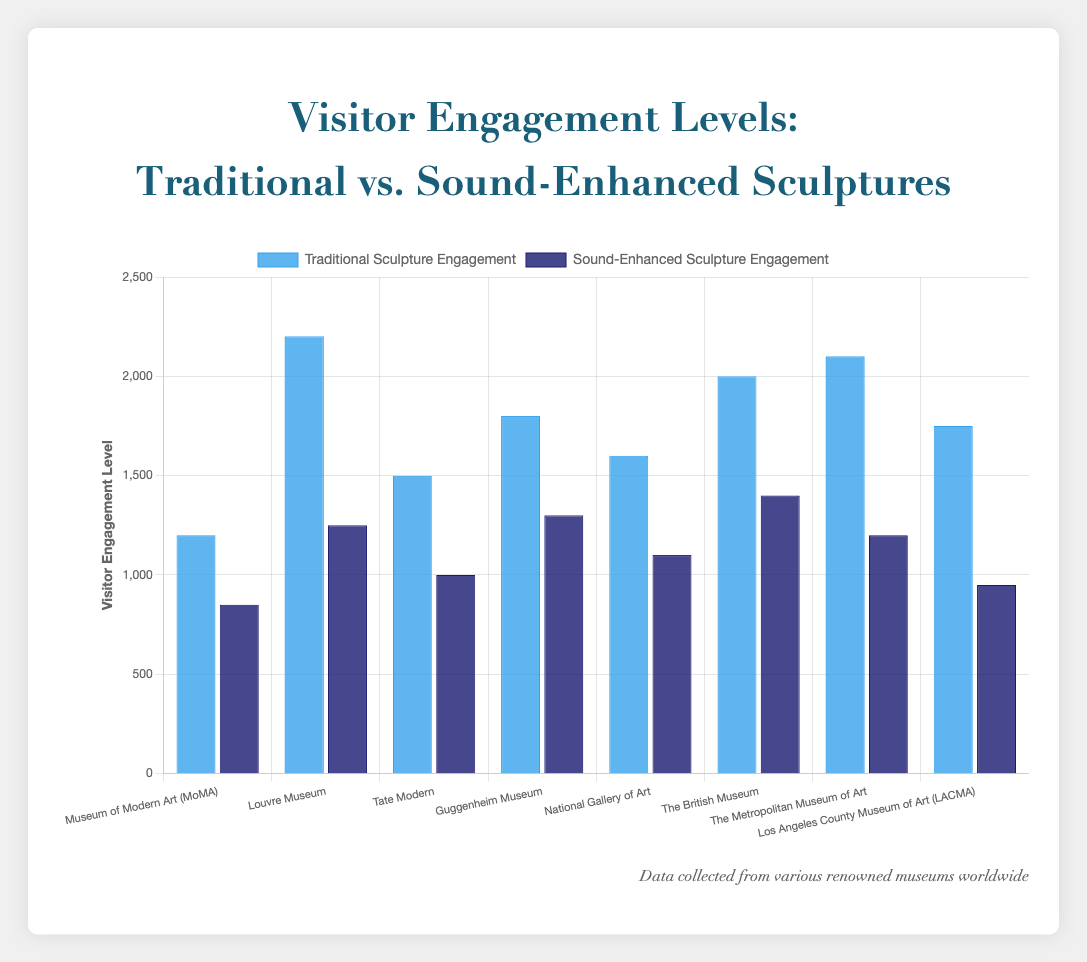What's the total engagement level for traditional sculptures across all museums? Sum up all the values for "Traditional Sculpture Engagement": 1200+2200+1500+1800+1600+2000+2100+1750 = 14150
Answer: 14150 Which museum has the largest difference in engagement between traditional and sound-enhanced sculptures? And what's the difference? Calculate the differences for each museum and identify the maximum difference: MoMA (1200-850=350), Louvre (2200-1250=950), Tate Modern (1500-1000=500), Guggenheim (1800-1300=500), National Gallery (1600-1100=500), British Museum (2000-1400=600), Met (2100-1200=900), LACMA (1750-950=800); The Louvre Museum has the largest difference of 950.
Answer: Louvre Museum, 950 Which museum has the highest engagement with traditional sculptures? Compare the engagement values for "Traditional Sculpture Engagement" and identify the highest: The Metropolitan Museum of Art with 2100.
Answer: The Metropolitan Museum of Art How much more is the total engagement for traditional sculptures compared to sound-enhanced sculptures across all museums? Calculate the total for both categories and find the difference: Traditional (14150) vs. Sound-Enhanced (950+1250+1000+1300+1100+1400+1200+950=9150); Difference = 14150-9150 = 5000
Answer: 5000 Which museum shows the smallest gap in engagement between traditional and sound-enhanced sculptures? Calculate the differences for each museum and find the smallest: MoMA (350), Louvre (950), Tate Modern (500), Guggenheim (500), National Gallery (500), British Museum (600), Met (900), LACMA (800); The Museum of Modern Art (MoMA) shows the smallest gap of 350.
Answer: Museum of Modern Art (MoMA) Is there any museum where sound-enhanced sculpture engagement exceeds 1300? Check the "Sound-Enhanced Sculpture Engagement" values; All values are ≤ 1300, so no.
Answer: No On average, how many visitors engage with sound-enhanced sculptures per museum? Sum up the values for "Sound-Enhanced Sculpture Engagement" and divide by the number of museums: (950+1250+1000+1300+1100+1400+1200+950)/8 = 9150/8 = 1143.75
Answer: 1143.75 Which visual attribute differentiates the traditional sculpture bars from the sound-enhanced sculpture bars? The colors of the bars are different, with traditional sculpture bars in blue and sound-enhanced sculpture bars in dark blue.
Answer: Colors (blue vs. dark blue) Is there any museum where traditional sculpture engagement is lower than 1500? Check the "Traditional Sculpture Engagement" values: MoMA (1200) and Tate Modern (1500); Only MoMA has lower engagement than 1500.
Answer: Yes, MoMA 